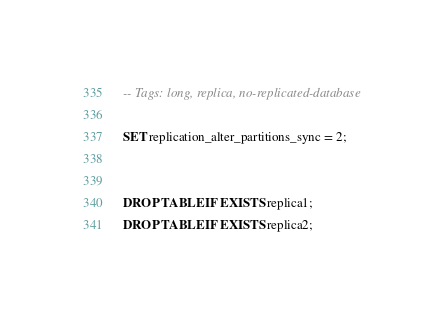Convert code to text. <code><loc_0><loc_0><loc_500><loc_500><_SQL_>-- Tags: long, replica, no-replicated-database

SET replication_alter_partitions_sync = 2;


DROP TABLE IF EXISTS replica1;
DROP TABLE IF EXISTS replica2;
</code> 